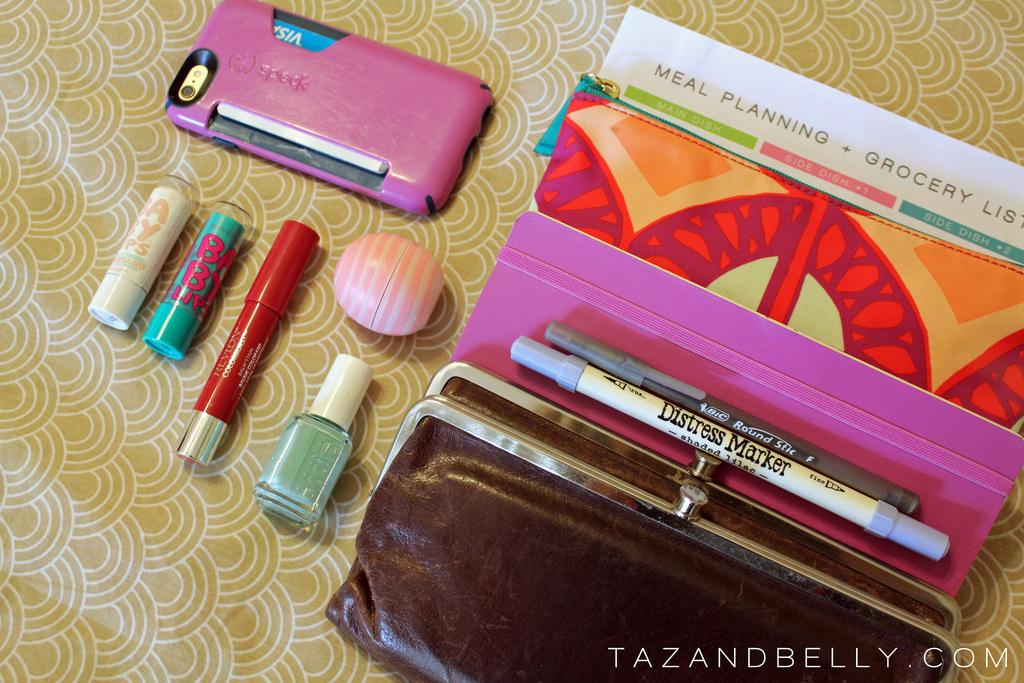What is the main object in the image? There is a mobile in the image. What cosmetic items can be seen in the image? There is lip balm, lipstick, and nail paint in the image. What type of bag is present in the image? There is a bag in the image. Are there any artistic elements in the image? Yes, there are sketches in the image. What is the color of the box in the image? There is a pink color box in the image. How many trains can be seen in the image? There are no trains present in the image. What type of liquid is being used in the image? There is no liquid present in the image. 